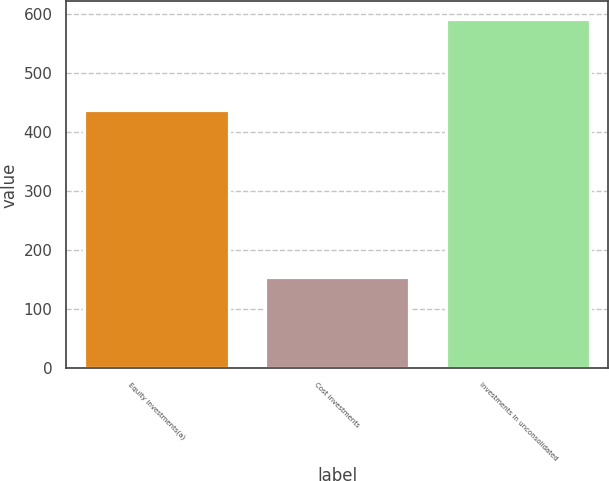Convert chart. <chart><loc_0><loc_0><loc_500><loc_500><bar_chart><fcel>Equity investments(a)<fcel>Cost investments<fcel>Investments in unconsolidated<nl><fcel>437<fcel>154<fcel>591<nl></chart> 